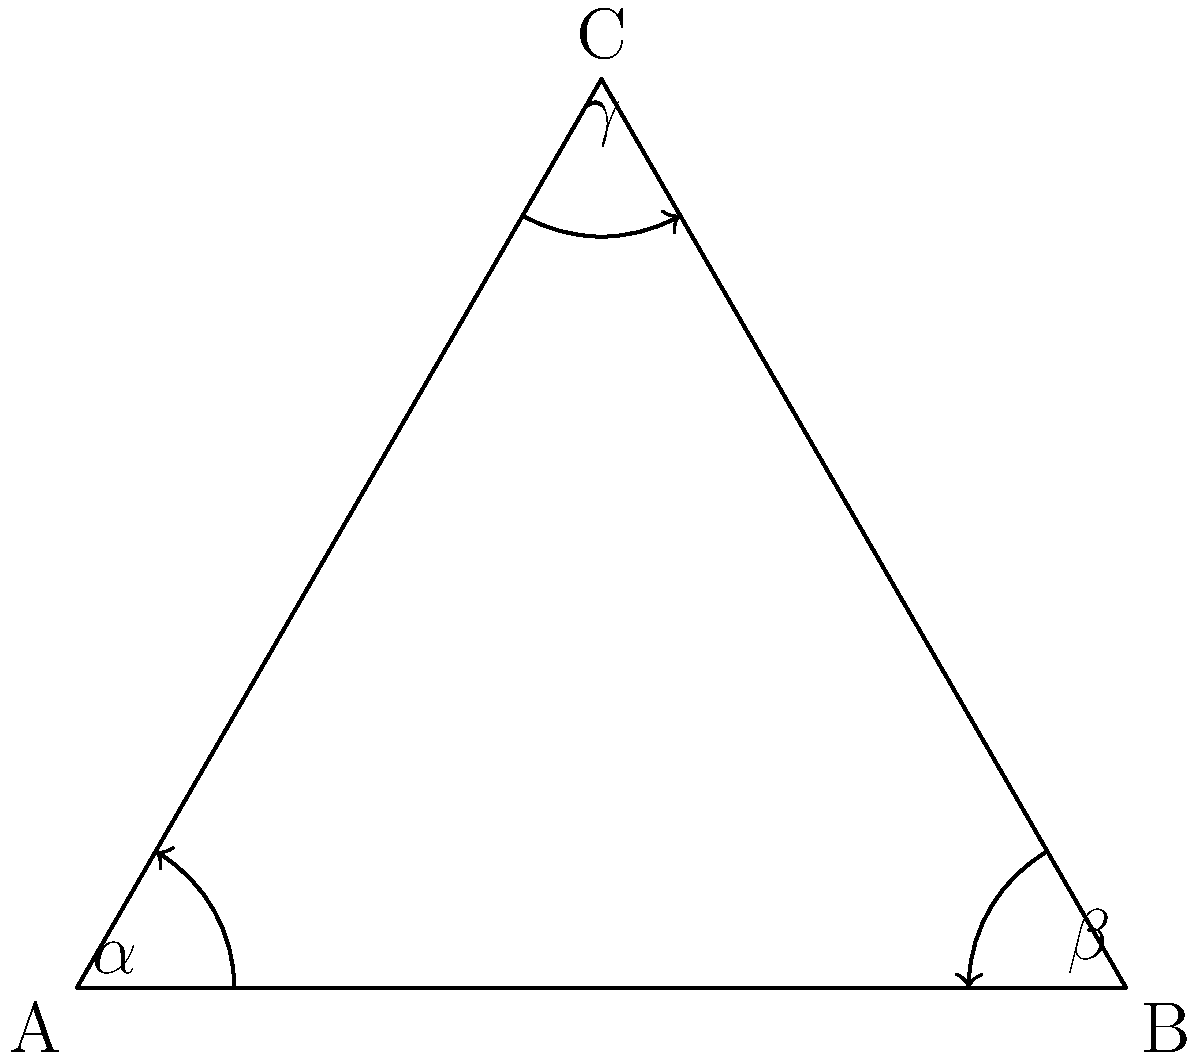During a training session on hyperbolic geometry, you encounter a problem involving a hyperbolic triangle. Given that the sum of the angles in a hyperbolic triangle is always less than 180°, calculate the defect of the triangle if its angles are $\alpha = 50°$, $\beta = 60°$, and $\gamma = 40°$. How might understanding this concept relate to following marshaller's signals in aviation? To solve this problem and understand its relevance to aviation, let's follow these steps:

1) In Euclidean geometry, the sum of angles in a triangle is always 180°. However, in hyperbolic geometry, this sum is always less than 180°.

2) The defect of a hyperbolic triangle is defined as the difference between 180° and the sum of the triangle's angles.

3) Let's calculate the sum of the given angles:
   $\alpha + \beta + \gamma = 50° + 60° + 40° = 150°$

4) Now, we can calculate the defect:
   Defect = $180° - (\alpha + \beta + \gamma)$
   Defect = $180° - 150° = 30°$

5) Relevance to aviation and marshaller's signals:
   Understanding non-Euclidean geometry, like hyperbolic geometry, trains pilots to think in three-dimensional space and consider curvature. This is crucial when:
   - Interpreting visual signals from marshallers, which are 2D representations of 3D movements.
   - Understanding the curvature of the Earth's surface during long-distance flights.
   - Visualizing and navigating in 3D airspace, especially in complex airport environments.

Just as the sum of angles in a hyperbolic triangle is less than expected, the apparent angles and distances in aviation can be different from what they seem, emphasizing the importance of precise interpretation of signals and instruments.
Answer: 30° 